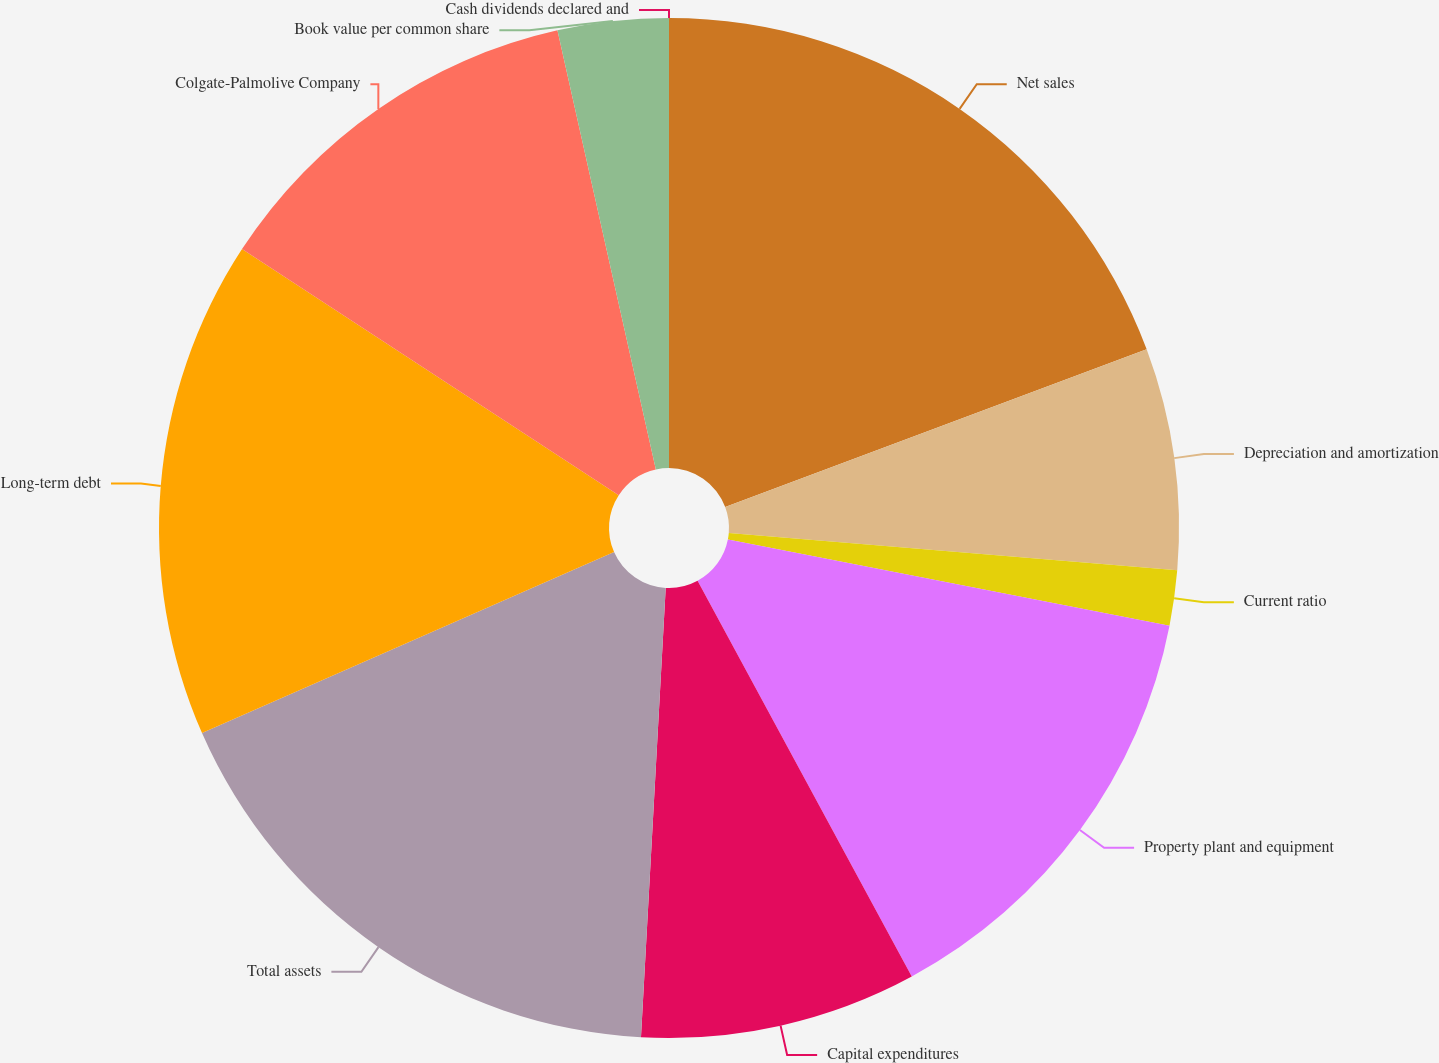Convert chart. <chart><loc_0><loc_0><loc_500><loc_500><pie_chart><fcel>Net sales<fcel>Depreciation and amortization<fcel>Current ratio<fcel>Property plant and equipment<fcel>Capital expenditures<fcel>Total assets<fcel>Long-term debt<fcel>Colgate-Palmolive Company<fcel>Book value per common share<fcel>Cash dividends declared and<nl><fcel>19.3%<fcel>7.02%<fcel>1.75%<fcel>14.03%<fcel>8.77%<fcel>17.54%<fcel>15.79%<fcel>12.28%<fcel>3.51%<fcel>0.0%<nl></chart> 